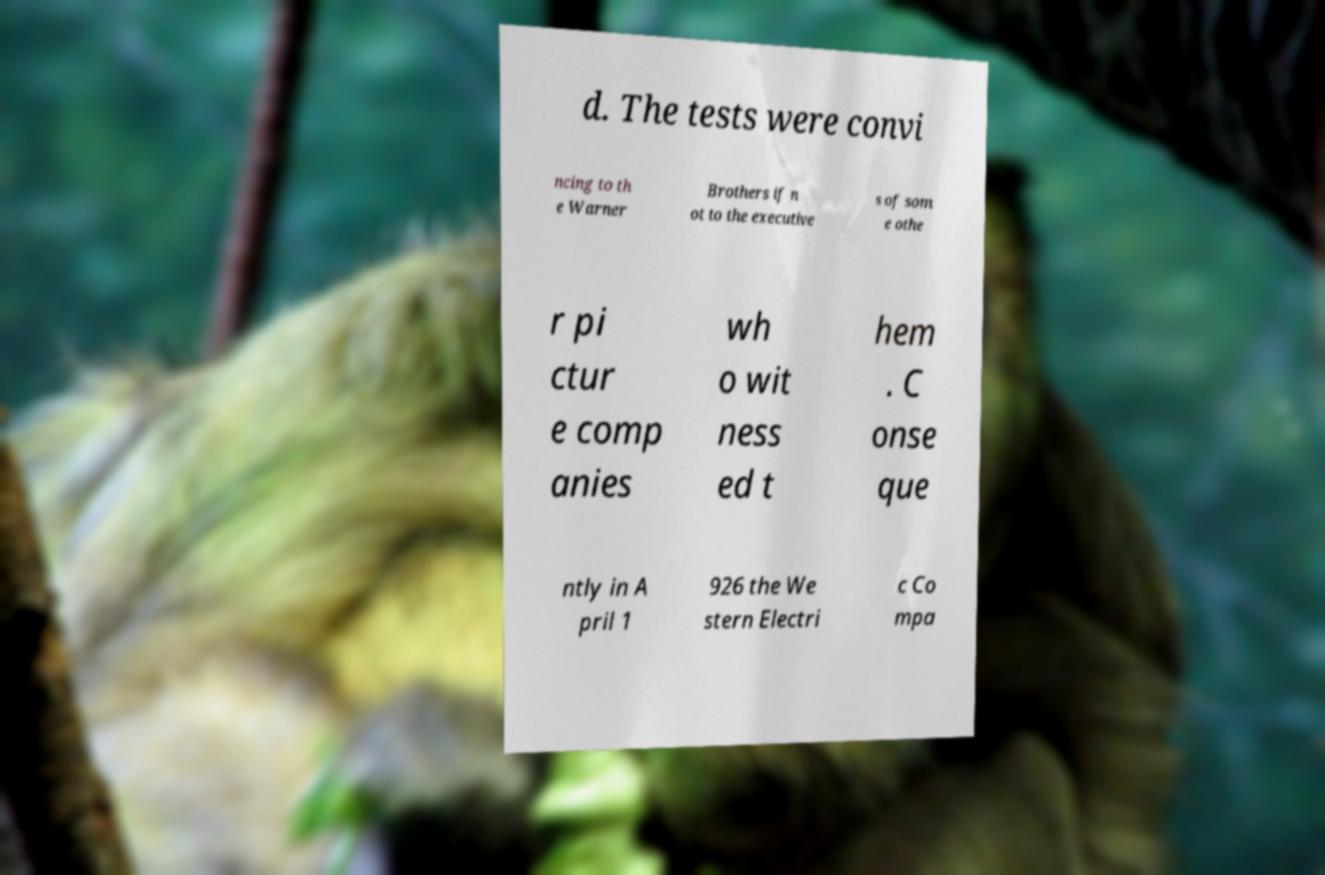For documentation purposes, I need the text within this image transcribed. Could you provide that? d. The tests were convi ncing to th e Warner Brothers if n ot to the executive s of som e othe r pi ctur e comp anies wh o wit ness ed t hem . C onse que ntly in A pril 1 926 the We stern Electri c Co mpa 